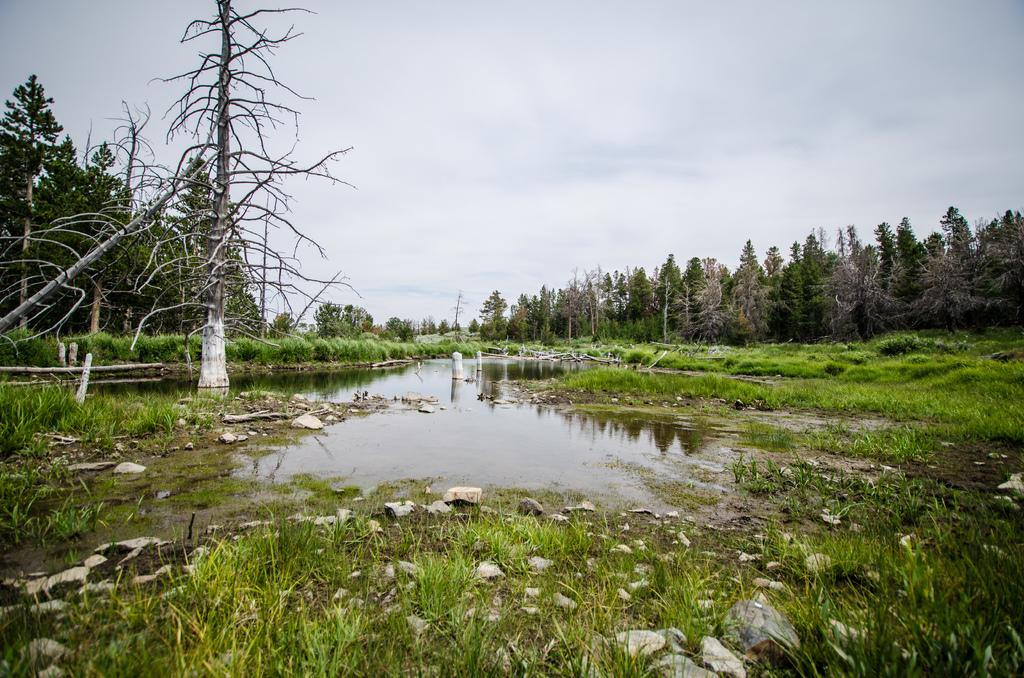What is the primary element visible in the image? There is water in the image. What type of vegetation can be seen in the image? There is grass, plants, and trees in the image. Are there any objects made of a hard material in the image? Yes, there are stones in the image. What can be seen in the background of the image? There are trees and the sky visible in the background of the image. What type of print can be seen on the judge's robe in the image? There is no judge or robe present in the image; it features water, grass, plants, stones, trees, and the sky. 